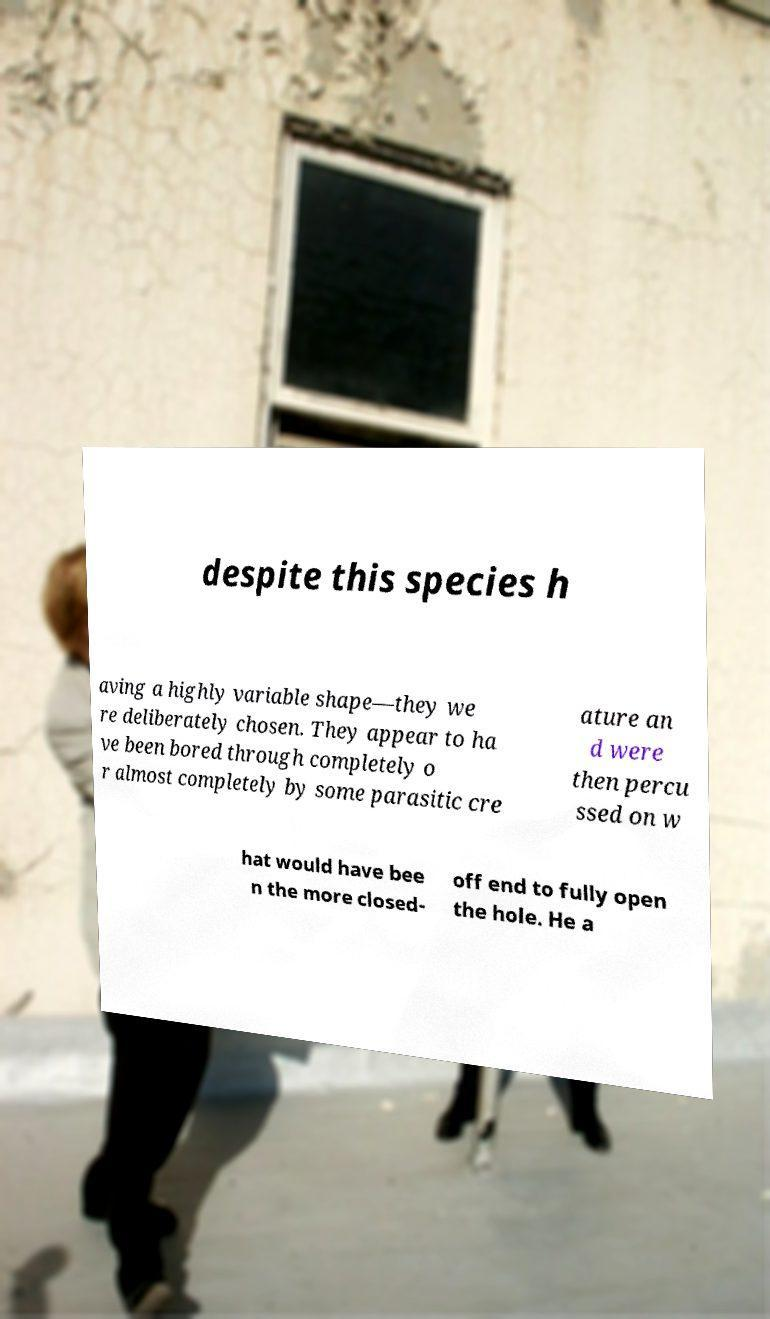Could you extract and type out the text from this image? despite this species h aving a highly variable shape—they we re deliberately chosen. They appear to ha ve been bored through completely o r almost completely by some parasitic cre ature an d were then percu ssed on w hat would have bee n the more closed- off end to fully open the hole. He a 